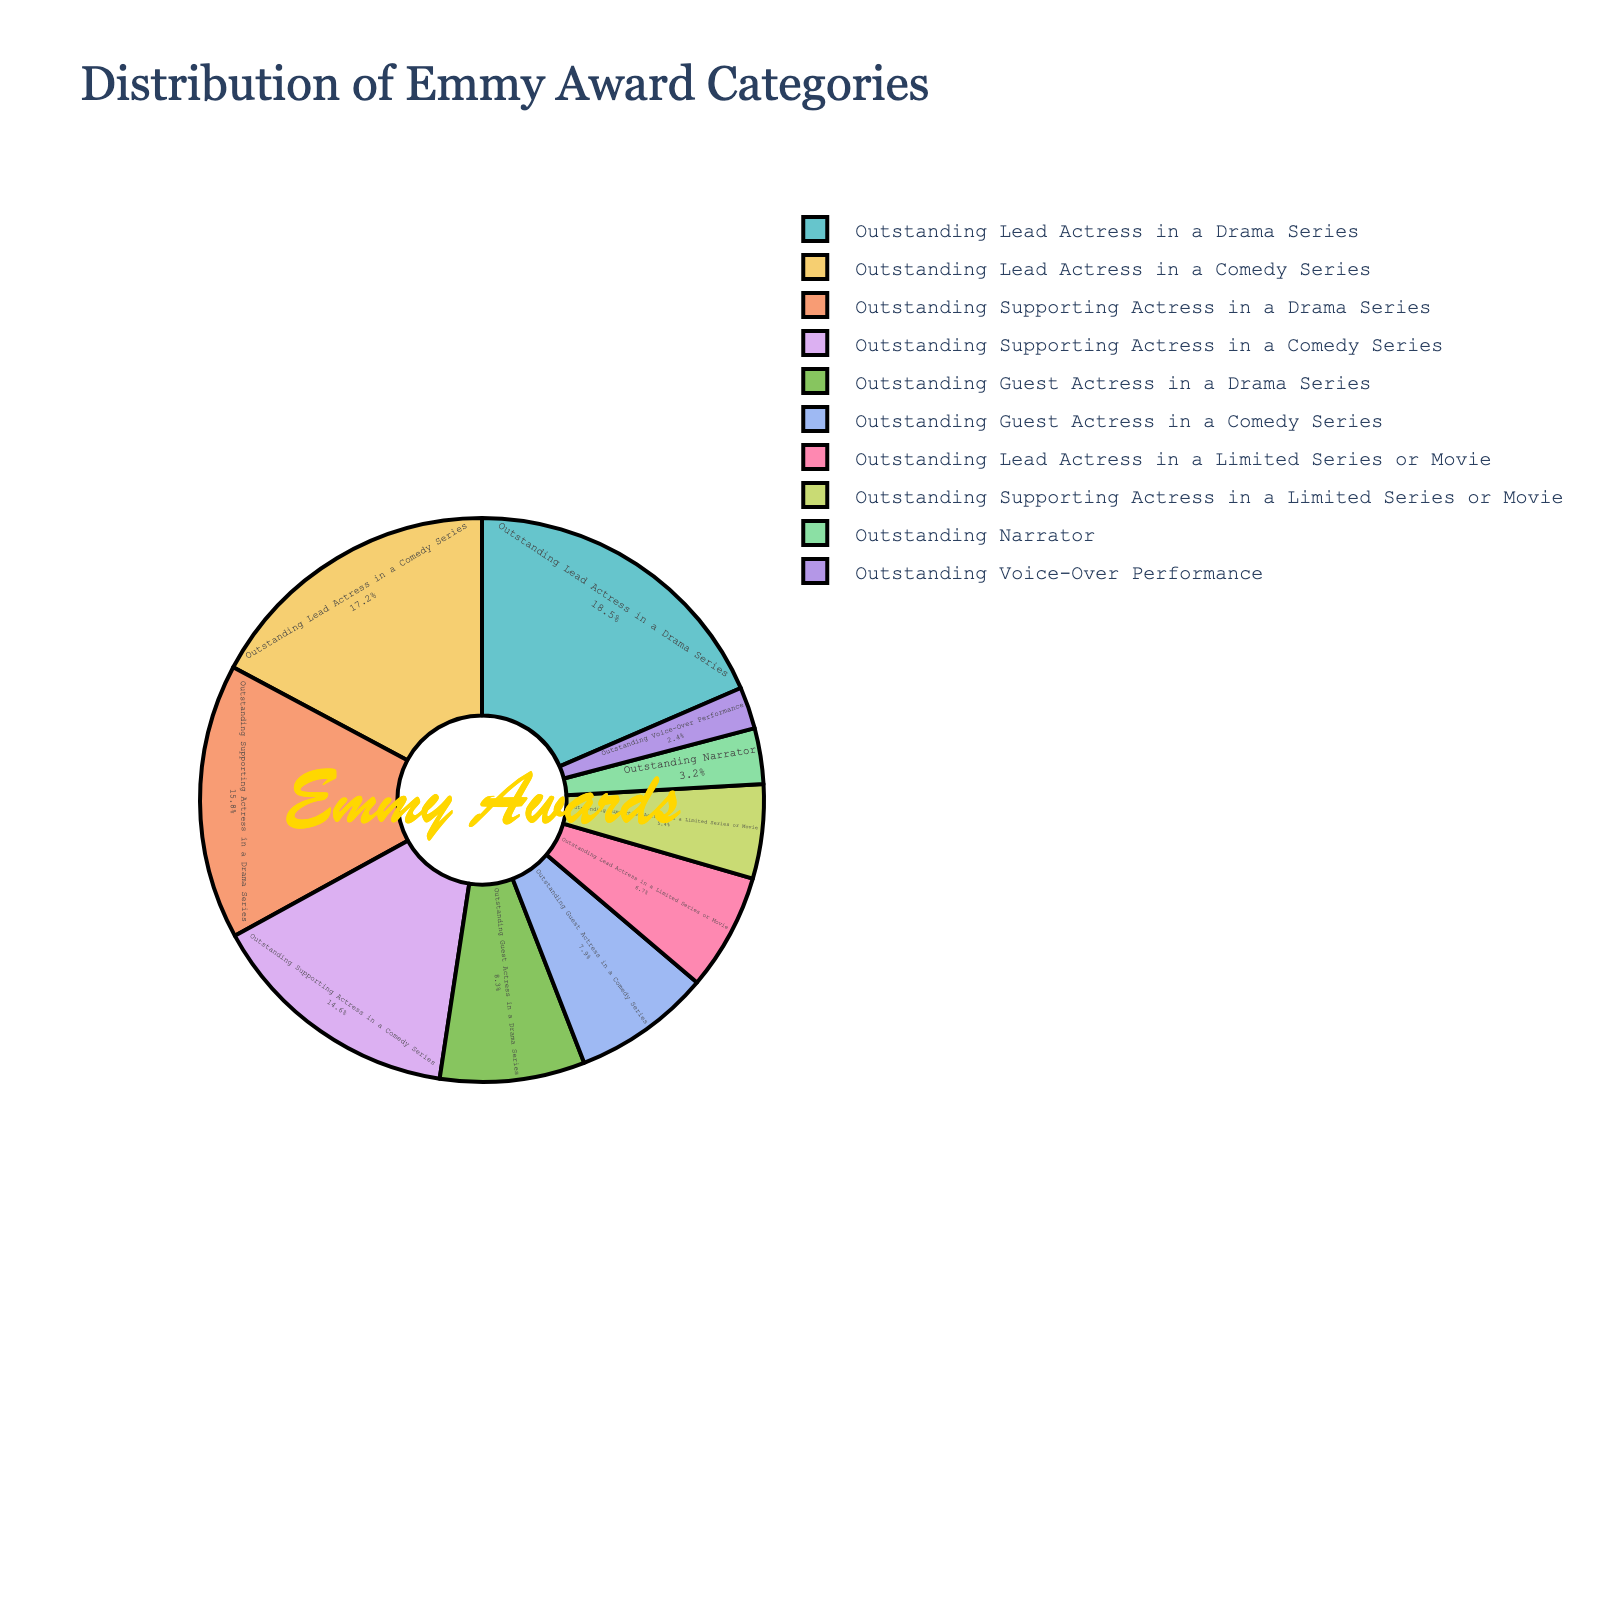What's the total percentage of lead actress categories combined? Add the percentages of "Outstanding Lead Actress in a Drama Series", "Outstanding Lead Actress in a Comedy Series", and "Outstanding Lead Actress in a Limited Series or Movie": 18.5% + 17.2% + 6.7%
Answer: 42.4% Which category has the lowest percentage? Identify the category with the smallest value in the chart: "Outstanding Voice-Over Performance" is the smallest with 2.4%
Answer: Outstanding Voice-Over Performance Which category has a higher percentage: Guest Actress in a Comedy Series or Guest Actress in a Drama Series? Compare the percentages of "Outstanding Guest Actress in a Comedy Series" (7.9%) and "Outstanding Guest Actress in a Drama Series" (8.3%): 8.3% is greater than 7.9%
Answer: Outstanding Guest Actress in a Drama Series What's the difference in percentage between Supporting Actress in a Comedy Series and Supporting Actress in a Drama Series? Subtract the percentage of "Outstanding Supporting Actress in a Comedy Series" (14.6%) from "Outstanding Supporting Actress in a Drama Series" (15.8%): 15.8% - 14.6% = 1.2%
Answer: 1.2% What is the combined percentage of the categories that have a percentage less than 10%? Add the percentages of categories with less than 10%: "Outstanding Guest Actress in a Drama Series" (8.3%), "Outstanding Guest Actress in a Comedy Series" (7.9%), "Outstanding Lead Actress in a Limited Series or Movie" (6.7%), "Outstanding Supporting Actress in a Limited Series or Movie" (5.4%), "Outstanding Narrator" (3.2%), "Outstanding Voice-Over Performance" (2.4%): 8.3% + 7.9% + 6.7% + 5.4% + 3.2% + 2.4%
Answer: 33.9% Of the top three categories in terms of percentage, by how much does the leading category exceed the third one? The top three categories are "Outstanding Lead Actress in a Drama Series" (18.5%), "Outstanding Lead Actress in a Comedy Series" (17.2%), and "Outstanding Supporting Actress in a Drama Series" (15.8%). Subtract the third's percentage from the first's: 18.5% - 15.8% = 2.7%
Answer: 2.7% What percentage of the pie chart is not occupied by the top two categories? Add the percentages of the top two categories: 18.5% + 17.2% = 35.7%. Subtract this from 100%: 100% - 35.7% = 64.3%
Answer: 64.3% Are there more categories with a percentage greater than 10% or less than 10%? Count categories >10%: 5 ("Outstanding Lead Actress in a Drama Series", "Outstanding Lead Actress in a Comedy Series", "Outstanding Supporting Actress in a Drama Series", "Outstanding Supporting Actress in a Comedy Series", "Outstanding Guest Actress in a Drama Series"). Count categories <10%: 5 ("Outstanding Guest Actress in a Comedy Series", "Outstanding Lead Actress in a Limited Series or Movie", "Outstanding Supporting Actress in a Limited Series or Movie", "Outstanding Narrator", "Outstanding Voice-Over Performance"). Both counts are equal
Answer: Equal 